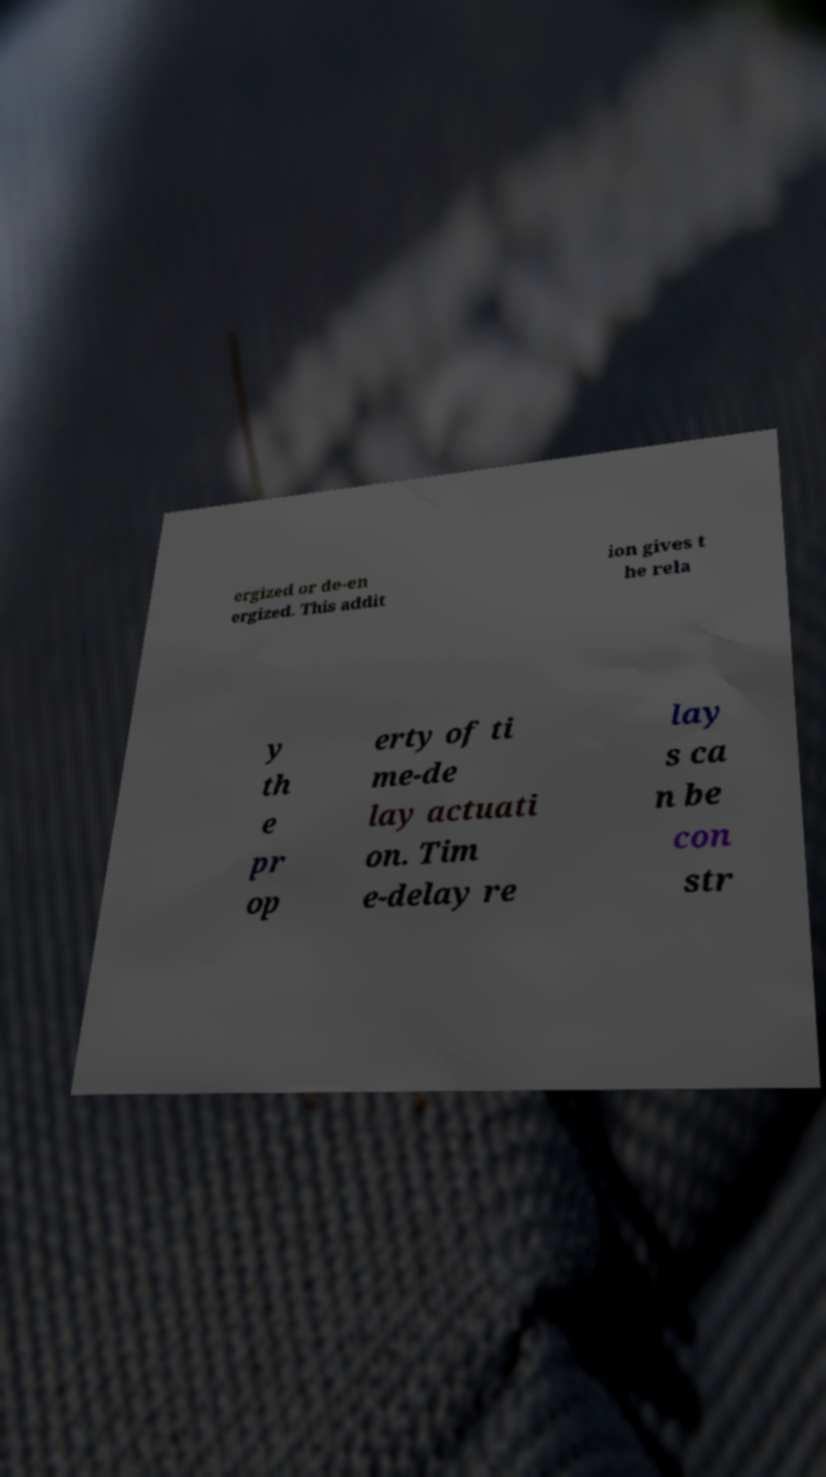I need the written content from this picture converted into text. Can you do that? ergized or de-en ergized. This addit ion gives t he rela y th e pr op erty of ti me-de lay actuati on. Tim e-delay re lay s ca n be con str 